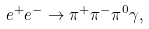<formula> <loc_0><loc_0><loc_500><loc_500>e ^ { + } e ^ { - } \to \pi ^ { + } \pi ^ { - } \pi ^ { 0 } \gamma ,</formula> 